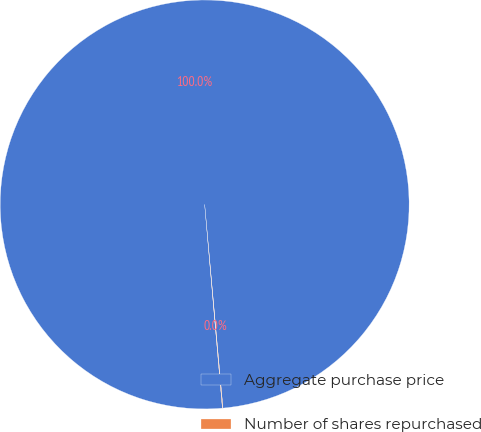Convert chart. <chart><loc_0><loc_0><loc_500><loc_500><pie_chart><fcel>Aggregate purchase price<fcel>Number of shares repurchased<nl><fcel>99.96%<fcel>0.04%<nl></chart> 